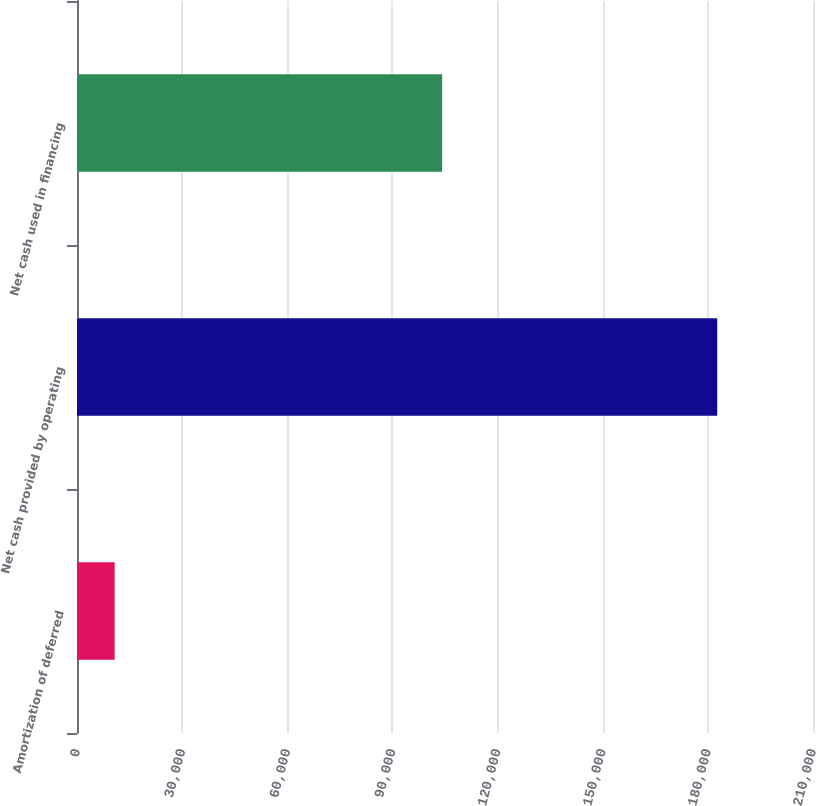Convert chart. <chart><loc_0><loc_0><loc_500><loc_500><bar_chart><fcel>Amortization of deferred<fcel>Net cash provided by operating<fcel>Net cash used in financing<nl><fcel>10748<fcel>182673<fcel>104187<nl></chart> 